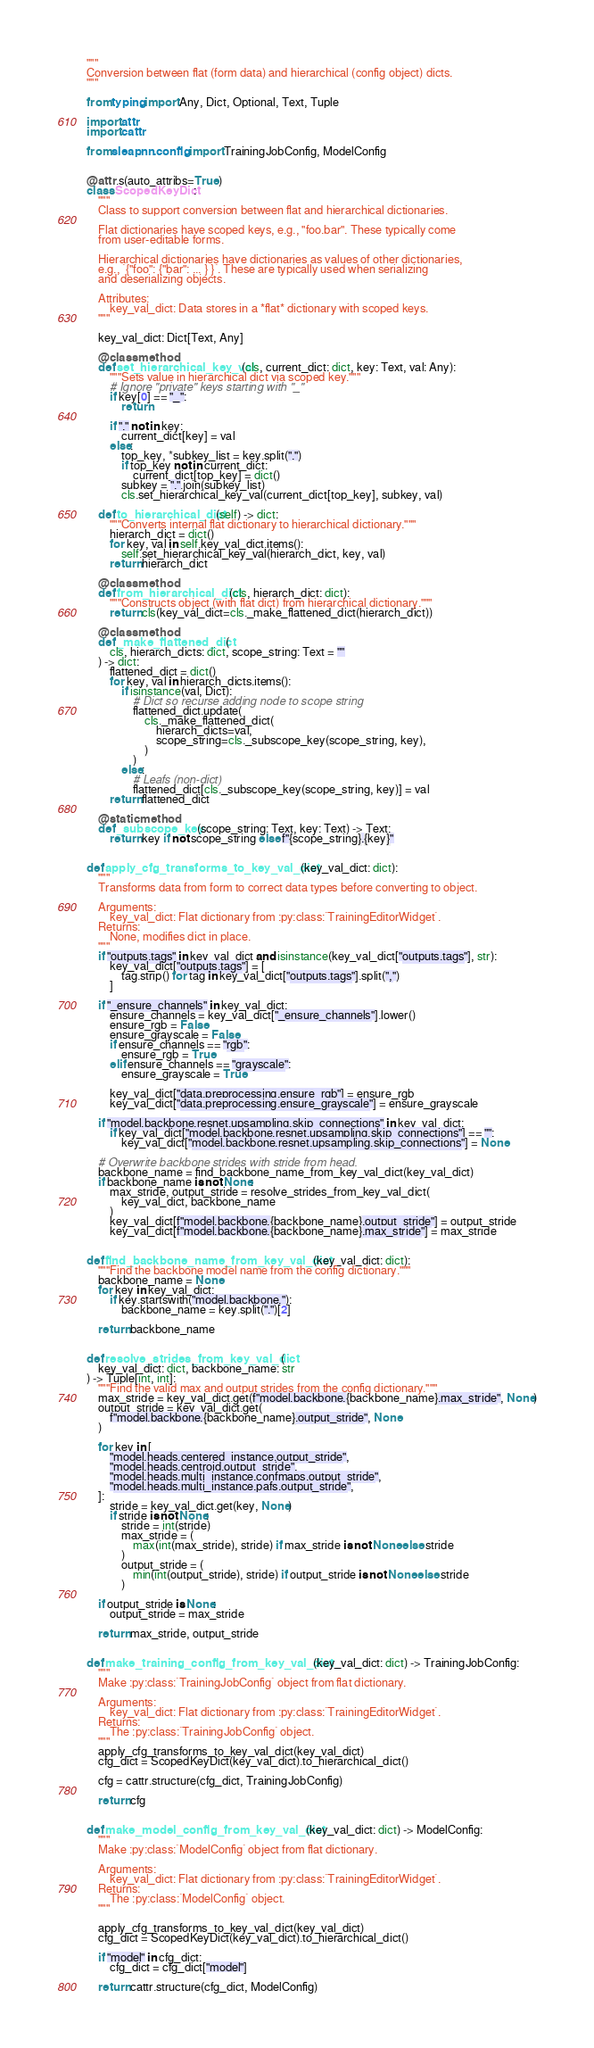<code> <loc_0><loc_0><loc_500><loc_500><_Python_>"""
Conversion between flat (form data) and hierarchical (config object) dicts.
"""

from typing import Any, Dict, Optional, Text, Tuple

import attr
import cattr

from sleap.nn.config import TrainingJobConfig, ModelConfig


@attr.s(auto_attribs=True)
class ScopedKeyDict:
    """
    Class to support conversion between flat and hierarchical dictionaries.

    Flat dictionaries have scoped keys, e.g., "foo.bar". These typically come
    from user-editable forms.

    Hierarchical dictionaries have dictionaries as values of other dictionaries,
    e.g., `{"foo": {"bar": ... } }`. These are typically used when serializing
    and deserializing objects.

    Attributes:
        key_val_dict: Data stores in a *flat* dictionary with scoped keys.
    """

    key_val_dict: Dict[Text, Any]

    @classmethod
    def set_hierarchical_key_val(cls, current_dict: dict, key: Text, val: Any):
        """Sets value in hierarchical dict via scoped key."""
        # Ignore "private" keys starting with "_"
        if key[0] == "_":
            return

        if "." not in key:
            current_dict[key] = val
        else:
            top_key, *subkey_list = key.split(".")
            if top_key not in current_dict:
                current_dict[top_key] = dict()
            subkey = ".".join(subkey_list)
            cls.set_hierarchical_key_val(current_dict[top_key], subkey, val)

    def to_hierarchical_dict(self) -> dict:
        """Converts internal flat dictionary to hierarchical dictionary."""
        hierarch_dict = dict()
        for key, val in self.key_val_dict.items():
            self.set_hierarchical_key_val(hierarch_dict, key, val)
        return hierarch_dict

    @classmethod
    def from_hierarchical_dict(cls, hierarch_dict: dict):
        """Constructs object (with flat dict) from hierarchical dictionary."""
        return cls(key_val_dict=cls._make_flattened_dict(hierarch_dict))

    @classmethod
    def _make_flattened_dict(
        cls, hierarch_dicts: dict, scope_string: Text = ""
    ) -> dict:
        flattened_dict = dict()
        for key, val in hierarch_dicts.items():
            if isinstance(val, Dict):
                # Dict so recurse adding node to scope string
                flattened_dict.update(
                    cls._make_flattened_dict(
                        hierarch_dicts=val,
                        scope_string=cls._subscope_key(scope_string, key),
                    )
                )
            else:
                # Leafs (non-dict)
                flattened_dict[cls._subscope_key(scope_string, key)] = val
        return flattened_dict

    @staticmethod
    def _subscope_key(scope_string: Text, key: Text) -> Text:
        return key if not scope_string else f"{scope_string}.{key}"


def apply_cfg_transforms_to_key_val_dict(key_val_dict: dict):
    """
    Transforms data from form to correct data types before converting to object.

    Arguments:
        key_val_dict: Flat dictionary from :py:class:`TrainingEditorWidget`.
    Returns:
        None, modifies dict in place.
    """
    if "outputs.tags" in key_val_dict and isinstance(key_val_dict["outputs.tags"], str):
        key_val_dict["outputs.tags"] = [
            tag.strip() for tag in key_val_dict["outputs.tags"].split(",")
        ]

    if "_ensure_channels" in key_val_dict:
        ensure_channels = key_val_dict["_ensure_channels"].lower()
        ensure_rgb = False
        ensure_grayscale = False
        if ensure_channels == "rgb":
            ensure_rgb = True
        elif ensure_channels == "grayscale":
            ensure_grayscale = True

        key_val_dict["data.preprocessing.ensure_rgb"] = ensure_rgb
        key_val_dict["data.preprocessing.ensure_grayscale"] = ensure_grayscale

    if "model.backbone.resnet.upsampling.skip_connections" in key_val_dict:
        if key_val_dict["model.backbone.resnet.upsampling.skip_connections"] == "":
            key_val_dict["model.backbone.resnet.upsampling.skip_connections"] = None

    # Overwrite backbone strides with stride from head.
    backbone_name = find_backbone_name_from_key_val_dict(key_val_dict)
    if backbone_name is not None:
        max_stride, output_stride = resolve_strides_from_key_val_dict(
            key_val_dict, backbone_name
        )
        key_val_dict[f"model.backbone.{backbone_name}.output_stride"] = output_stride
        key_val_dict[f"model.backbone.{backbone_name}.max_stride"] = max_stride


def find_backbone_name_from_key_val_dict(key_val_dict: dict):
    """Find the backbone model name from the config dictionary."""
    backbone_name = None
    for key in key_val_dict:
        if key.startswith("model.backbone."):
            backbone_name = key.split(".")[2]

    return backbone_name


def resolve_strides_from_key_val_dict(
    key_val_dict: dict, backbone_name: str
) -> Tuple[int, int]:
    """Find the valid max and output strides from the config dictionary."""
    max_stride = key_val_dict.get(f"model.backbone.{backbone_name}.max_stride", None)
    output_stride = key_val_dict.get(
        f"model.backbone.{backbone_name}.output_stride", None
    )

    for key in [
        "model.heads.centered_instance.output_stride",
        "model.heads.centroid.output_stride",
        "model.heads.multi_instance.confmaps.output_stride",
        "model.heads.multi_instance.pafs.output_stride",
    ]:
        stride = key_val_dict.get(key, None)
        if stride is not None:
            stride = int(stride)
            max_stride = (
                max(int(max_stride), stride) if max_stride is not None else stride
            )
            output_stride = (
                min(int(output_stride), stride) if output_stride is not None else stride
            )

    if output_stride is None:
        output_stride = max_stride

    return max_stride, output_stride


def make_training_config_from_key_val_dict(key_val_dict: dict) -> TrainingJobConfig:
    """
    Make :py:class:`TrainingJobConfig` object from flat dictionary.

    Arguments:
        key_val_dict: Flat dictionary from :py:class:`TrainingEditorWidget`.
    Returns:
        The :py:class:`TrainingJobConfig` object.
    """
    apply_cfg_transforms_to_key_val_dict(key_val_dict)
    cfg_dict = ScopedKeyDict(key_val_dict).to_hierarchical_dict()

    cfg = cattr.structure(cfg_dict, TrainingJobConfig)

    return cfg


def make_model_config_from_key_val_dict(key_val_dict: dict) -> ModelConfig:
    """
    Make :py:class:`ModelConfig` object from flat dictionary.

    Arguments:
        key_val_dict: Flat dictionary from :py:class:`TrainingEditorWidget`.
    Returns:
        The :py:class:`ModelConfig` object.
    """

    apply_cfg_transforms_to_key_val_dict(key_val_dict)
    cfg_dict = ScopedKeyDict(key_val_dict).to_hierarchical_dict()

    if "model" in cfg_dict:
        cfg_dict = cfg_dict["model"]

    return cattr.structure(cfg_dict, ModelConfig)
</code> 